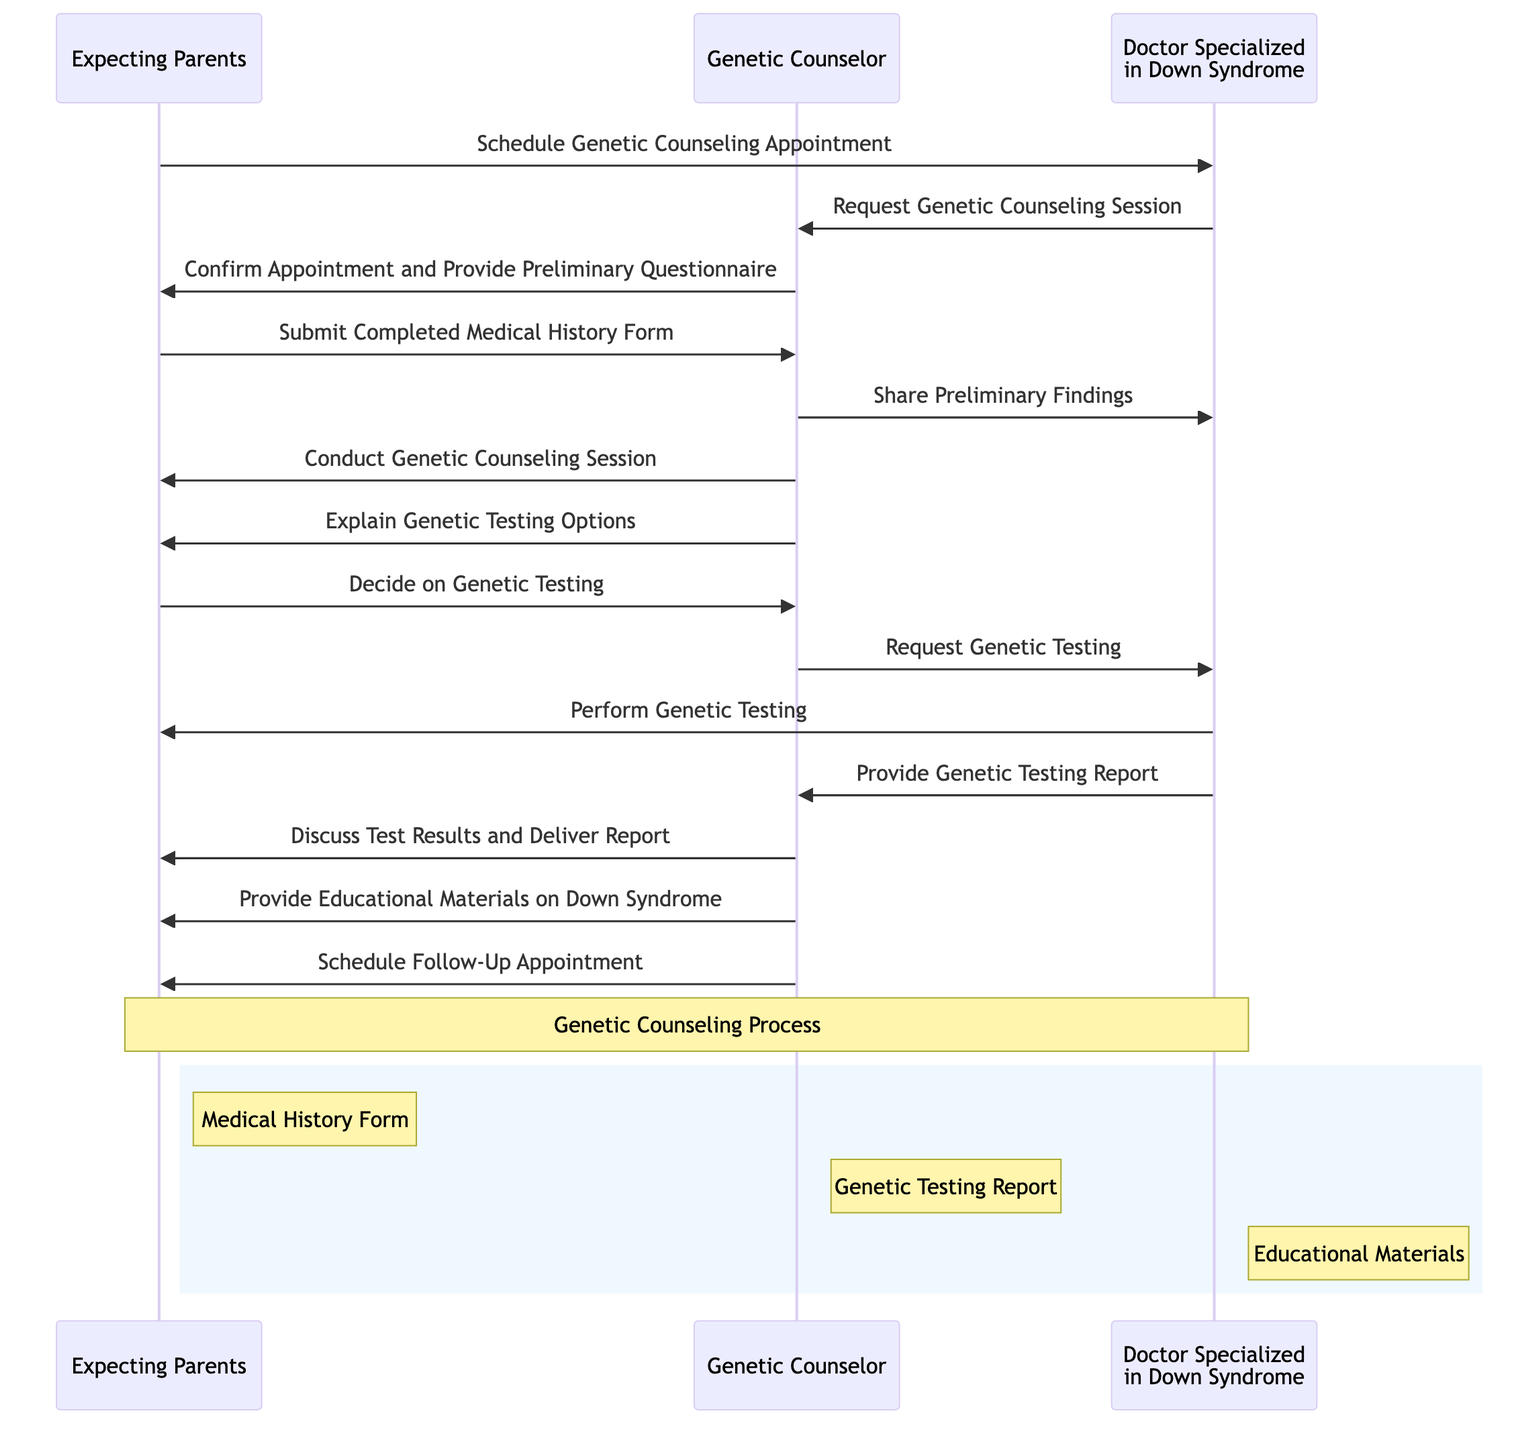What is the first action taken by the Expecting Parents? The first action taken by the Expecting Parents is to schedule a genetic counseling appointment, as depicted in the first message from Expecting Parents to Doctor Specialized in Down Syndrome.
Answer: Schedule Genetic Counseling Appointment How many main actors are in the diagram? There are three main actors depicted in the diagram: Expecting Parents, Genetic Counselor, and Doctor Specialized in Down Syndrome.
Answer: Three Who confirms the appointment for genetic counseling? The Genetic Counselor confirms the appointment for genetic counseling as shown in the message directed from Genetic Counselor to Expecting Parents that states they confirm the appointment.
Answer: Genetic Counselor What type of materials does the Genetic Counselor provide to Expecting Parents? The Genetic Counselor provides educational materials on Down Syndrome as indicated in the message from Genetic Counselor to Expecting Parents detailing this sharing of information.
Answer: Educational Materials on Down Syndrome What is the relationship between the Genetic Counselor and Doctor Specialized in Down Syndrome after the medical history form is submitted? After the medical history form is submitted by the Expecting Parents, the Genetic Counselor shares preliminary findings with the Doctor Specialized in Down Syndrome, indicating that they are collaborating on the case.
Answer: Share Preliminary Findings How many distinct messages involve the Expecting Parents? There are five distinct messages that involve the Expecting Parents throughout the sequence of events depicted in the diagram, illustrating their active participation.
Answer: Five What occurs after the genetic counseling session is conducted? After the genetic counseling session, the Genetic Counselor explains genetic testing options to the Expecting Parents, indicating the progression of the process following the session.
Answer: Explain Genetic Testing Options What action follows the decision on genetic testing made by the Expecting Parents? Following the decision on genetic testing, the Genetic Counselor requests genetic testing from the Doctor Specialized in Down Syndrome as the next step in the process.
Answer: Request Genetic Testing What is the final action performed by the Genetic Counselor in this sequence? The final action performed by the Genetic Counselor in this sequence is to schedule a follow-up appointment, indicating the conclusion of the counseling process.
Answer: Schedule Follow-Up Appointment 